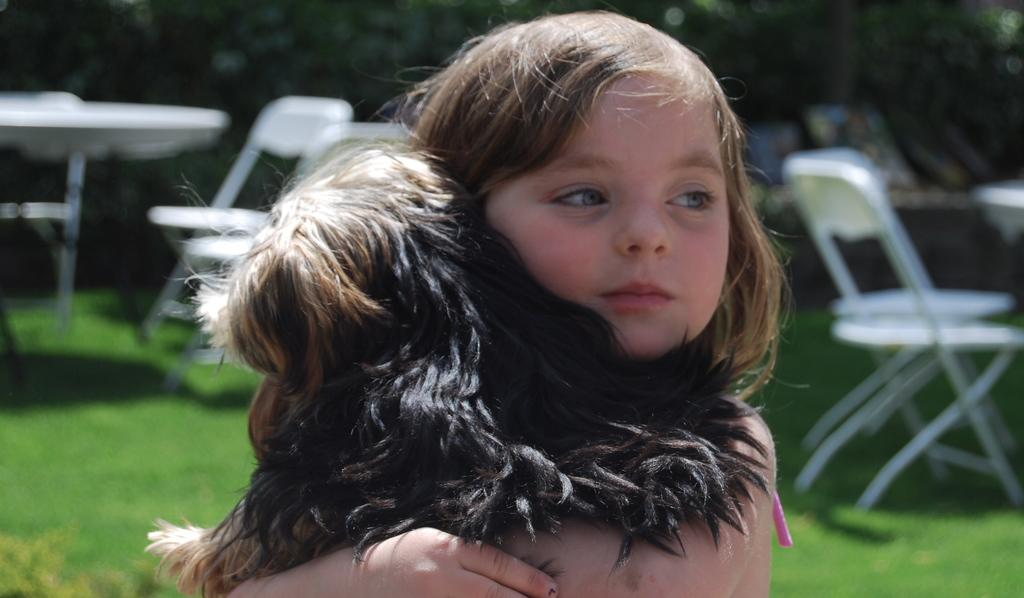Who is present in the image? There is a girl in the image. What is the girl holding in the image? The girl is holding an animal. What type of furniture can be seen in the background of the image? There are chairs and a table in the background of the image. What type of natural environment is visible in the background of the image? There is grass visible in the background of the image. What type of toad is the girl selecting in the image? There is no toad present in the image, and the girl is not shown selecting anything. 